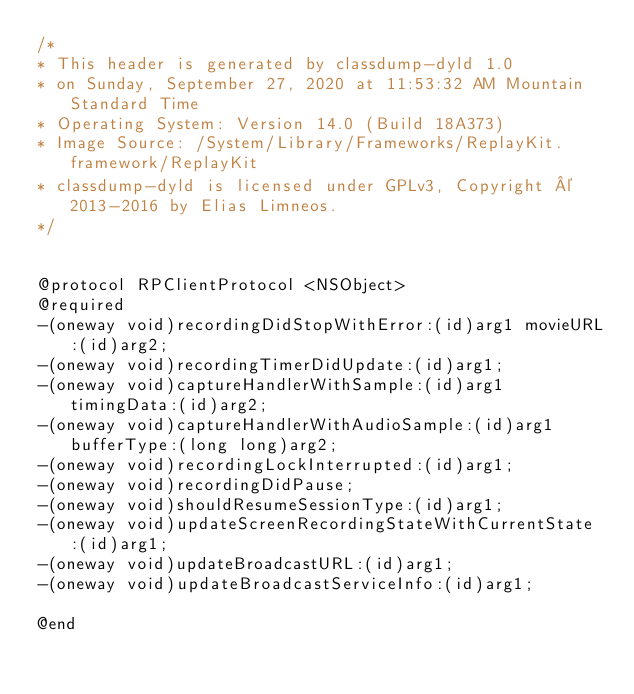<code> <loc_0><loc_0><loc_500><loc_500><_C_>/*
* This header is generated by classdump-dyld 1.0
* on Sunday, September 27, 2020 at 11:53:32 AM Mountain Standard Time
* Operating System: Version 14.0 (Build 18A373)
* Image Source: /System/Library/Frameworks/ReplayKit.framework/ReplayKit
* classdump-dyld is licensed under GPLv3, Copyright © 2013-2016 by Elias Limneos.
*/


@protocol RPClientProtocol <NSObject>
@required
-(oneway void)recordingDidStopWithError:(id)arg1 movieURL:(id)arg2;
-(oneway void)recordingTimerDidUpdate:(id)arg1;
-(oneway void)captureHandlerWithSample:(id)arg1 timingData:(id)arg2;
-(oneway void)captureHandlerWithAudioSample:(id)arg1 bufferType:(long long)arg2;
-(oneway void)recordingLockInterrupted:(id)arg1;
-(oneway void)recordingDidPause;
-(oneway void)shouldResumeSessionType:(id)arg1;
-(oneway void)updateScreenRecordingStateWithCurrentState:(id)arg1;
-(oneway void)updateBroadcastURL:(id)arg1;
-(oneway void)updateBroadcastServiceInfo:(id)arg1;

@end

</code> 